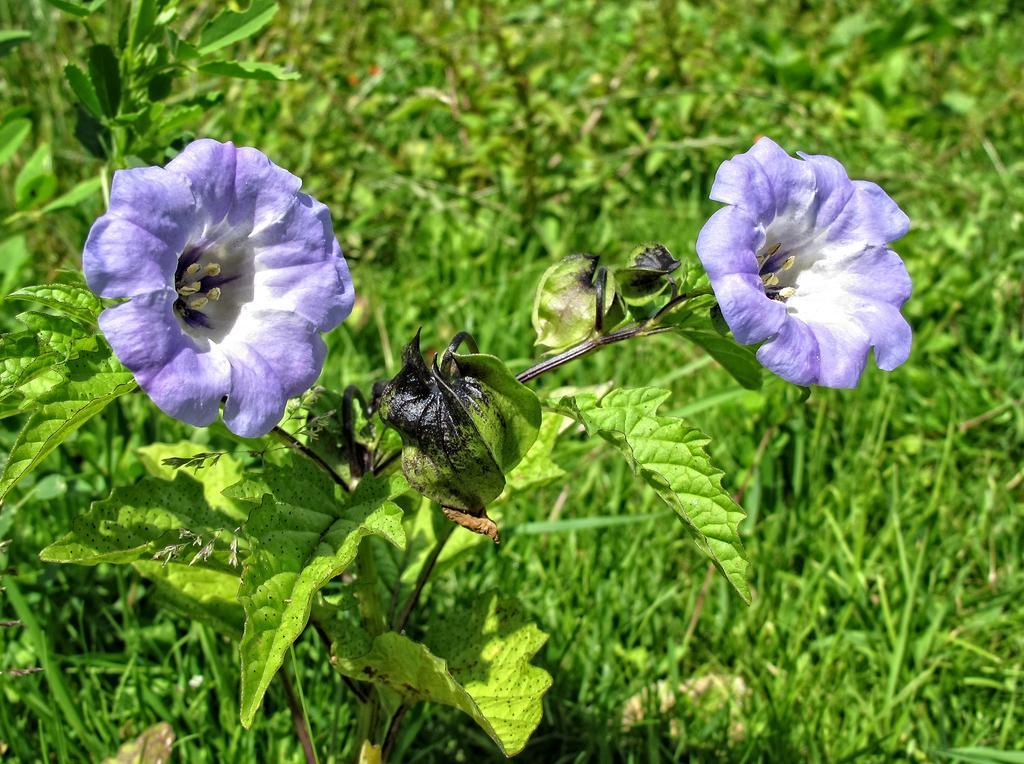In one or two sentences, can you explain what this image depicts? In front of the image there are flowers with leaves and stems, behind the flowers there is grass on the surface. 